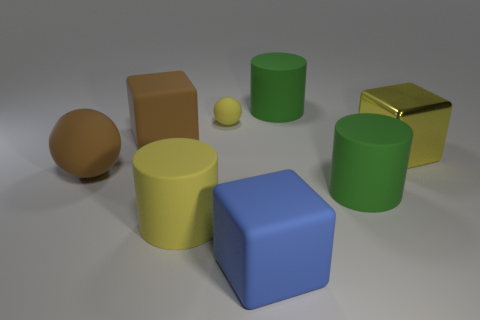Do the large rubber ball and the metal cube have the same color?
Make the answer very short. No. Are the yellow thing that is in front of the big shiny object and the yellow object on the right side of the big blue matte cube made of the same material?
Keep it short and to the point. No. How many objects are large gray matte blocks or things right of the big yellow cylinder?
Provide a short and direct response. 5. Is there any other thing that has the same material as the tiny sphere?
Provide a succinct answer. Yes. What is the shape of the big metal thing that is the same color as the small object?
Provide a short and direct response. Cube. What is the brown block made of?
Offer a very short reply. Rubber. Is the large brown sphere made of the same material as the big blue object?
Provide a short and direct response. Yes. How many metal objects are big yellow cylinders or balls?
Keep it short and to the point. 0. There is a matte object behind the yellow sphere; what shape is it?
Your answer should be compact. Cylinder. The yellow thing that is made of the same material as the small ball is what size?
Give a very brief answer. Large. 